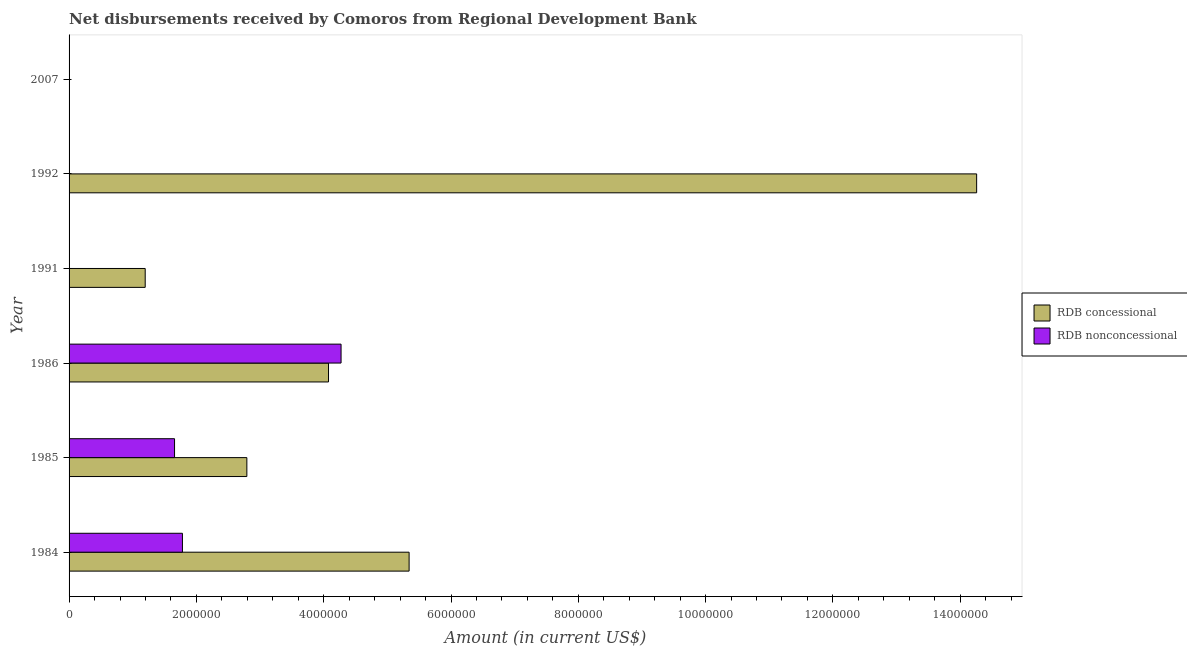How many different coloured bars are there?
Provide a short and direct response. 2. Are the number of bars on each tick of the Y-axis equal?
Ensure brevity in your answer.  No. What is the label of the 1st group of bars from the top?
Provide a succinct answer. 2007. In how many cases, is the number of bars for a given year not equal to the number of legend labels?
Provide a succinct answer. 3. Across all years, what is the maximum net concessional disbursements from rdb?
Keep it short and to the point. 1.43e+07. Across all years, what is the minimum net concessional disbursements from rdb?
Ensure brevity in your answer.  0. What is the total net non concessional disbursements from rdb in the graph?
Keep it short and to the point. 7.71e+06. What is the difference between the net non concessional disbursements from rdb in 1985 and that in 1986?
Provide a succinct answer. -2.62e+06. What is the difference between the net concessional disbursements from rdb in 1992 and the net non concessional disbursements from rdb in 1991?
Ensure brevity in your answer.  1.43e+07. What is the average net concessional disbursements from rdb per year?
Your answer should be very brief. 4.61e+06. In the year 1985, what is the difference between the net non concessional disbursements from rdb and net concessional disbursements from rdb?
Give a very brief answer. -1.14e+06. What is the ratio of the net concessional disbursements from rdb in 1991 to that in 1992?
Offer a terse response. 0.08. Is the net concessional disbursements from rdb in 1984 less than that in 1985?
Give a very brief answer. No. Is the difference between the net concessional disbursements from rdb in 1985 and 1986 greater than the difference between the net non concessional disbursements from rdb in 1985 and 1986?
Offer a terse response. Yes. What is the difference between the highest and the second highest net non concessional disbursements from rdb?
Offer a terse response. 2.49e+06. What is the difference between the highest and the lowest net concessional disbursements from rdb?
Make the answer very short. 1.43e+07. Is the sum of the net concessional disbursements from rdb in 1991 and 1992 greater than the maximum net non concessional disbursements from rdb across all years?
Ensure brevity in your answer.  Yes. How many bars are there?
Give a very brief answer. 8. How many years are there in the graph?
Provide a short and direct response. 6. What is the difference between two consecutive major ticks on the X-axis?
Your answer should be compact. 2.00e+06. How are the legend labels stacked?
Your answer should be very brief. Vertical. What is the title of the graph?
Provide a succinct answer. Net disbursements received by Comoros from Regional Development Bank. Does "Foreign Liabilities" appear as one of the legend labels in the graph?
Make the answer very short. No. What is the label or title of the Y-axis?
Give a very brief answer. Year. What is the Amount (in current US$) in RDB concessional in 1984?
Provide a succinct answer. 5.34e+06. What is the Amount (in current US$) of RDB nonconcessional in 1984?
Provide a succinct answer. 1.78e+06. What is the Amount (in current US$) of RDB concessional in 1985?
Keep it short and to the point. 2.79e+06. What is the Amount (in current US$) of RDB nonconcessional in 1985?
Provide a succinct answer. 1.66e+06. What is the Amount (in current US$) of RDB concessional in 1986?
Give a very brief answer. 4.08e+06. What is the Amount (in current US$) of RDB nonconcessional in 1986?
Give a very brief answer. 4.27e+06. What is the Amount (in current US$) in RDB concessional in 1991?
Keep it short and to the point. 1.20e+06. What is the Amount (in current US$) in RDB nonconcessional in 1991?
Provide a short and direct response. 0. What is the Amount (in current US$) in RDB concessional in 1992?
Offer a terse response. 1.43e+07. What is the Amount (in current US$) of RDB nonconcessional in 1992?
Provide a succinct answer. 0. Across all years, what is the maximum Amount (in current US$) of RDB concessional?
Provide a succinct answer. 1.43e+07. Across all years, what is the maximum Amount (in current US$) in RDB nonconcessional?
Offer a very short reply. 4.27e+06. What is the total Amount (in current US$) in RDB concessional in the graph?
Ensure brevity in your answer.  2.77e+07. What is the total Amount (in current US$) in RDB nonconcessional in the graph?
Ensure brevity in your answer.  7.71e+06. What is the difference between the Amount (in current US$) in RDB concessional in 1984 and that in 1985?
Your answer should be compact. 2.55e+06. What is the difference between the Amount (in current US$) of RDB nonconcessional in 1984 and that in 1985?
Provide a succinct answer. 1.24e+05. What is the difference between the Amount (in current US$) in RDB concessional in 1984 and that in 1986?
Offer a very short reply. 1.27e+06. What is the difference between the Amount (in current US$) in RDB nonconcessional in 1984 and that in 1986?
Provide a succinct answer. -2.49e+06. What is the difference between the Amount (in current US$) in RDB concessional in 1984 and that in 1991?
Your answer should be very brief. 4.15e+06. What is the difference between the Amount (in current US$) of RDB concessional in 1984 and that in 1992?
Make the answer very short. -8.92e+06. What is the difference between the Amount (in current US$) of RDB concessional in 1985 and that in 1986?
Give a very brief answer. -1.28e+06. What is the difference between the Amount (in current US$) of RDB nonconcessional in 1985 and that in 1986?
Your answer should be very brief. -2.62e+06. What is the difference between the Amount (in current US$) in RDB concessional in 1985 and that in 1991?
Your response must be concise. 1.60e+06. What is the difference between the Amount (in current US$) in RDB concessional in 1985 and that in 1992?
Your answer should be compact. -1.15e+07. What is the difference between the Amount (in current US$) in RDB concessional in 1986 and that in 1991?
Offer a terse response. 2.88e+06. What is the difference between the Amount (in current US$) in RDB concessional in 1986 and that in 1992?
Ensure brevity in your answer.  -1.02e+07. What is the difference between the Amount (in current US$) in RDB concessional in 1991 and that in 1992?
Ensure brevity in your answer.  -1.31e+07. What is the difference between the Amount (in current US$) in RDB concessional in 1984 and the Amount (in current US$) in RDB nonconcessional in 1985?
Your response must be concise. 3.68e+06. What is the difference between the Amount (in current US$) of RDB concessional in 1984 and the Amount (in current US$) of RDB nonconcessional in 1986?
Your answer should be very brief. 1.07e+06. What is the difference between the Amount (in current US$) of RDB concessional in 1985 and the Amount (in current US$) of RDB nonconcessional in 1986?
Ensure brevity in your answer.  -1.48e+06. What is the average Amount (in current US$) of RDB concessional per year?
Your response must be concise. 4.61e+06. What is the average Amount (in current US$) of RDB nonconcessional per year?
Keep it short and to the point. 1.29e+06. In the year 1984, what is the difference between the Amount (in current US$) of RDB concessional and Amount (in current US$) of RDB nonconcessional?
Give a very brief answer. 3.56e+06. In the year 1985, what is the difference between the Amount (in current US$) of RDB concessional and Amount (in current US$) of RDB nonconcessional?
Offer a terse response. 1.14e+06. In the year 1986, what is the difference between the Amount (in current US$) of RDB concessional and Amount (in current US$) of RDB nonconcessional?
Give a very brief answer. -1.97e+05. What is the ratio of the Amount (in current US$) in RDB concessional in 1984 to that in 1985?
Your answer should be compact. 1.91. What is the ratio of the Amount (in current US$) in RDB nonconcessional in 1984 to that in 1985?
Make the answer very short. 1.07. What is the ratio of the Amount (in current US$) in RDB concessional in 1984 to that in 1986?
Ensure brevity in your answer.  1.31. What is the ratio of the Amount (in current US$) in RDB nonconcessional in 1984 to that in 1986?
Keep it short and to the point. 0.42. What is the ratio of the Amount (in current US$) of RDB concessional in 1984 to that in 1991?
Make the answer very short. 4.47. What is the ratio of the Amount (in current US$) of RDB concessional in 1984 to that in 1992?
Your answer should be compact. 0.37. What is the ratio of the Amount (in current US$) in RDB concessional in 1985 to that in 1986?
Offer a terse response. 0.69. What is the ratio of the Amount (in current US$) of RDB nonconcessional in 1985 to that in 1986?
Keep it short and to the point. 0.39. What is the ratio of the Amount (in current US$) in RDB concessional in 1985 to that in 1991?
Ensure brevity in your answer.  2.34. What is the ratio of the Amount (in current US$) of RDB concessional in 1985 to that in 1992?
Provide a succinct answer. 0.2. What is the ratio of the Amount (in current US$) in RDB concessional in 1986 to that in 1991?
Offer a terse response. 3.41. What is the ratio of the Amount (in current US$) of RDB concessional in 1986 to that in 1992?
Provide a short and direct response. 0.29. What is the ratio of the Amount (in current US$) in RDB concessional in 1991 to that in 1992?
Your response must be concise. 0.08. What is the difference between the highest and the second highest Amount (in current US$) in RDB concessional?
Keep it short and to the point. 8.92e+06. What is the difference between the highest and the second highest Amount (in current US$) of RDB nonconcessional?
Your answer should be very brief. 2.49e+06. What is the difference between the highest and the lowest Amount (in current US$) in RDB concessional?
Provide a succinct answer. 1.43e+07. What is the difference between the highest and the lowest Amount (in current US$) of RDB nonconcessional?
Keep it short and to the point. 4.27e+06. 